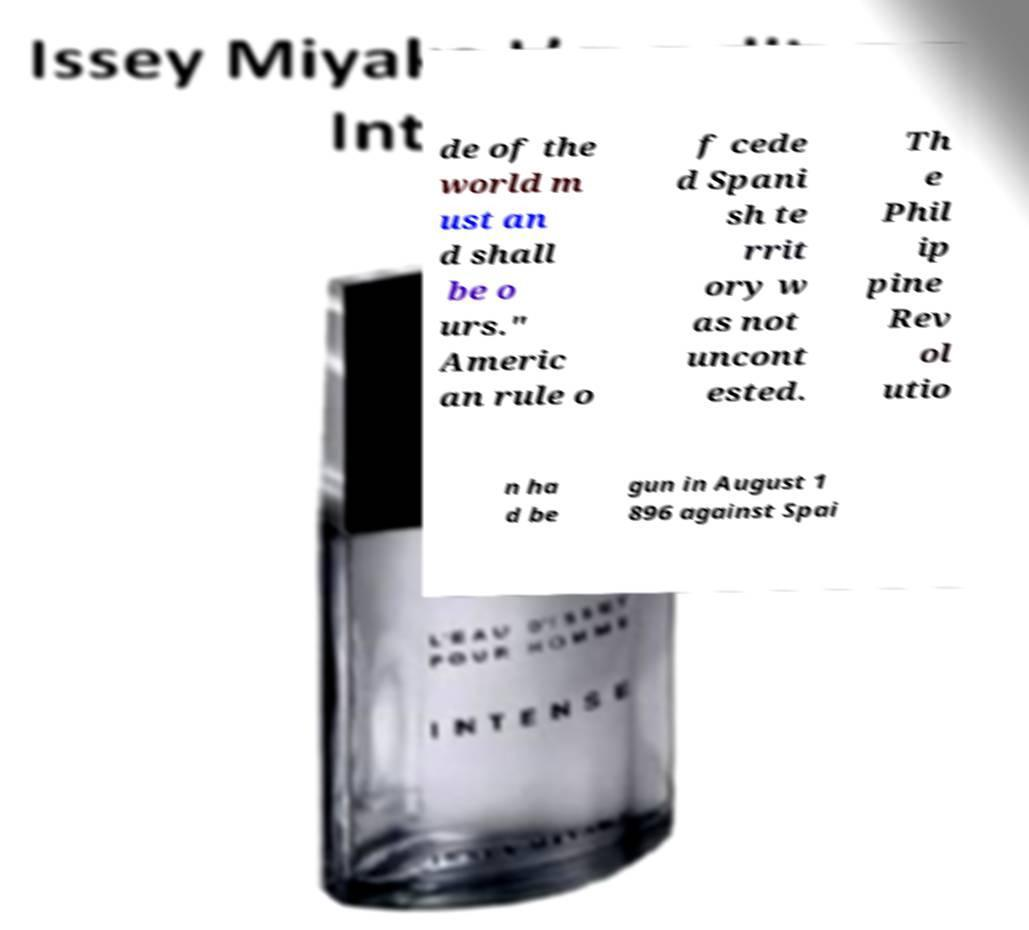What messages or text are displayed in this image? I need them in a readable, typed format. de of the world m ust an d shall be o urs." Americ an rule o f cede d Spani sh te rrit ory w as not uncont ested. Th e Phil ip pine Rev ol utio n ha d be gun in August 1 896 against Spai 